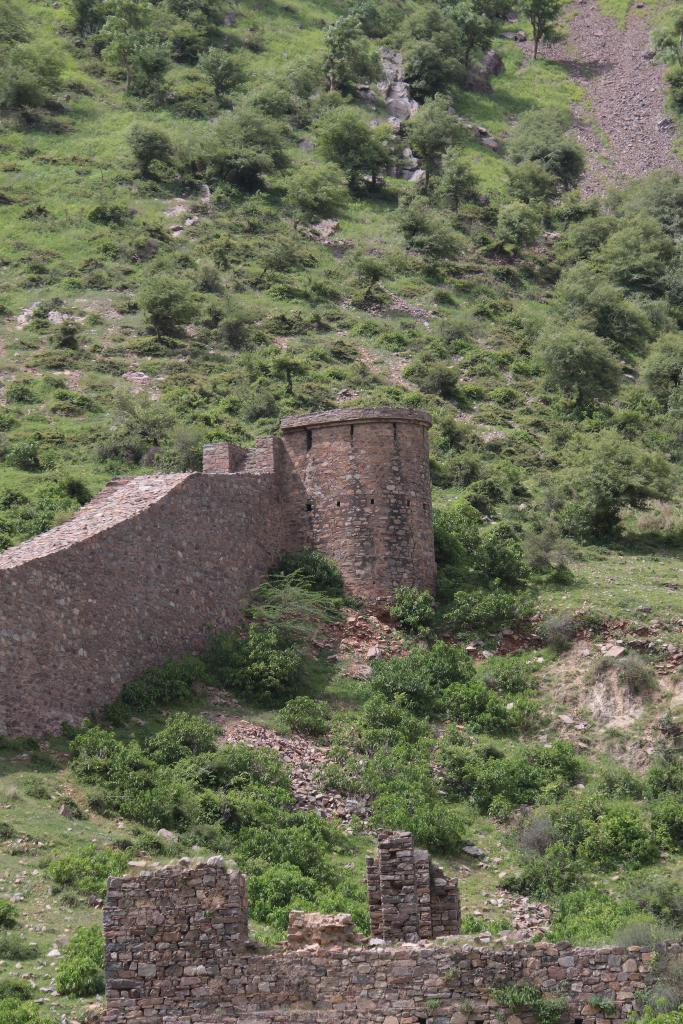What type of view is shown in the image? The image is an outside view. What is located at the bottom of the image? There is a wall at the bottom of the image. What can be seen on the left side of the image? There is a port on the left side of the image. What is present on the ground in the image? There are many plants and trees on the ground. How many boys are playing with the bat in the image? There are no boys or bats present in the image. 